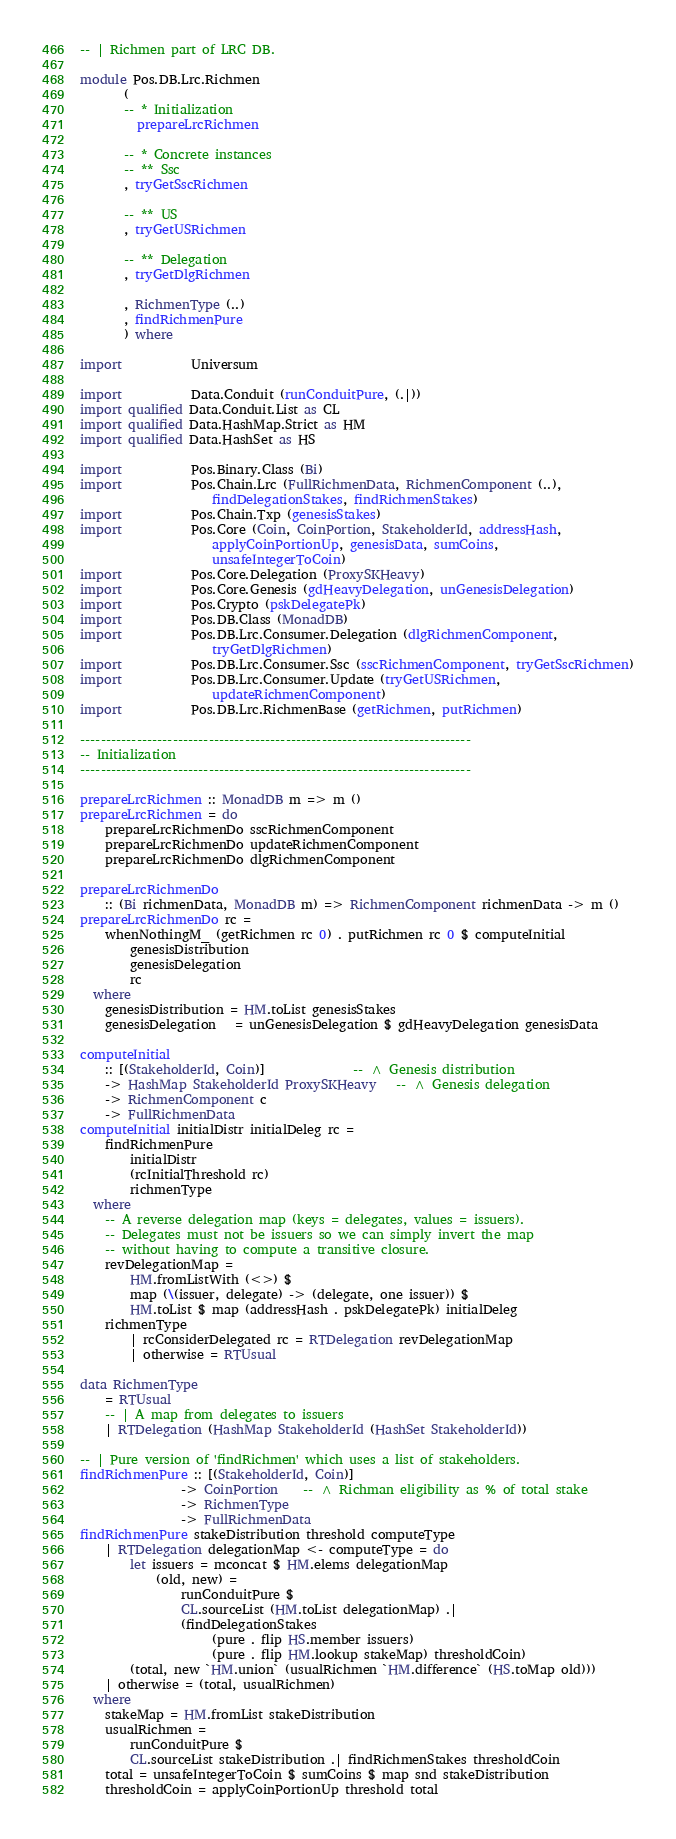Convert code to text. <code><loc_0><loc_0><loc_500><loc_500><_Haskell_>-- | Richmen part of LRC DB.

module Pos.DB.Lrc.Richmen
       (
       -- * Initialization
         prepareLrcRichmen

       -- * Concrete instances
       -- ** Ssc
       , tryGetSscRichmen

       -- ** US
       , tryGetUSRichmen

       -- ** Delegation
       , tryGetDlgRichmen

       , RichmenType (..)
       , findRichmenPure
       ) where

import           Universum

import           Data.Conduit (runConduitPure, (.|))
import qualified Data.Conduit.List as CL
import qualified Data.HashMap.Strict as HM
import qualified Data.HashSet as HS

import           Pos.Binary.Class (Bi)
import           Pos.Chain.Lrc (FullRichmenData, RichmenComponent (..),
                     findDelegationStakes, findRichmenStakes)
import           Pos.Chain.Txp (genesisStakes)
import           Pos.Core (Coin, CoinPortion, StakeholderId, addressHash,
                     applyCoinPortionUp, genesisData, sumCoins,
                     unsafeIntegerToCoin)
import           Pos.Core.Delegation (ProxySKHeavy)
import           Pos.Core.Genesis (gdHeavyDelegation, unGenesisDelegation)
import           Pos.Crypto (pskDelegatePk)
import           Pos.DB.Class (MonadDB)
import           Pos.DB.Lrc.Consumer.Delegation (dlgRichmenComponent,
                     tryGetDlgRichmen)
import           Pos.DB.Lrc.Consumer.Ssc (sscRichmenComponent, tryGetSscRichmen)
import           Pos.DB.Lrc.Consumer.Update (tryGetUSRichmen,
                     updateRichmenComponent)
import           Pos.DB.Lrc.RichmenBase (getRichmen, putRichmen)

----------------------------------------------------------------------------
-- Initialization
----------------------------------------------------------------------------

prepareLrcRichmen :: MonadDB m => m ()
prepareLrcRichmen = do
    prepareLrcRichmenDo sscRichmenComponent
    prepareLrcRichmenDo updateRichmenComponent
    prepareLrcRichmenDo dlgRichmenComponent

prepareLrcRichmenDo
    :: (Bi richmenData, MonadDB m) => RichmenComponent richmenData -> m ()
prepareLrcRichmenDo rc =
    whenNothingM_ (getRichmen rc 0) . putRichmen rc 0 $ computeInitial
        genesisDistribution
        genesisDelegation
        rc
  where
    genesisDistribution = HM.toList genesisStakes
    genesisDelegation   = unGenesisDelegation $ gdHeavyDelegation genesisData

computeInitial
    :: [(StakeholderId, Coin)]              -- ^ Genesis distribution
    -> HashMap StakeholderId ProxySKHeavy   -- ^ Genesis delegation
    -> RichmenComponent c
    -> FullRichmenData
computeInitial initialDistr initialDeleg rc =
    findRichmenPure
        initialDistr
        (rcInitialThreshold rc)
        richmenType
  where
    -- A reverse delegation map (keys = delegates, values = issuers).
    -- Delegates must not be issuers so we can simply invert the map
    -- without having to compute a transitive closure.
    revDelegationMap =
        HM.fromListWith (<>) $
        map (\(issuer, delegate) -> (delegate, one issuer)) $
        HM.toList $ map (addressHash . pskDelegatePk) initialDeleg
    richmenType
        | rcConsiderDelegated rc = RTDelegation revDelegationMap
        | otherwise = RTUsual

data RichmenType
    = RTUsual
    -- | A map from delegates to issuers
    | RTDelegation (HashMap StakeholderId (HashSet StakeholderId))

-- | Pure version of 'findRichmen' which uses a list of stakeholders.
findRichmenPure :: [(StakeholderId, Coin)]
                -> CoinPortion    -- ^ Richman eligibility as % of total stake
                -> RichmenType
                -> FullRichmenData
findRichmenPure stakeDistribution threshold computeType
    | RTDelegation delegationMap <- computeType = do
        let issuers = mconcat $ HM.elems delegationMap
            (old, new) =
                runConduitPure $
                CL.sourceList (HM.toList delegationMap) .|
                (findDelegationStakes
                     (pure . flip HS.member issuers)
                     (pure . flip HM.lookup stakeMap) thresholdCoin)
        (total, new `HM.union` (usualRichmen `HM.difference` (HS.toMap old)))
    | otherwise = (total, usualRichmen)
  where
    stakeMap = HM.fromList stakeDistribution
    usualRichmen =
        runConduitPure $
        CL.sourceList stakeDistribution .| findRichmenStakes thresholdCoin
    total = unsafeIntegerToCoin $ sumCoins $ map snd stakeDistribution
    thresholdCoin = applyCoinPortionUp threshold total
</code> 